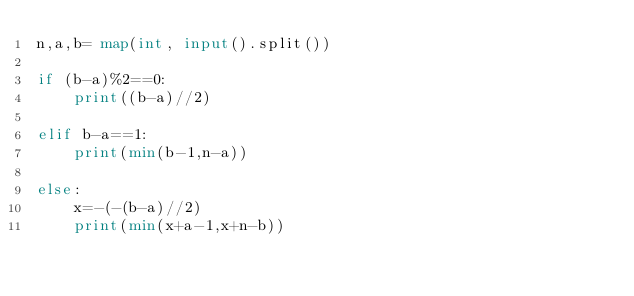<code> <loc_0><loc_0><loc_500><loc_500><_Python_>n,a,b= map(int, input().split())

if (b-a)%2==0:
    print((b-a)//2)

elif b-a==1:
    print(min(b-1,n-a))

else:
    x=-(-(b-a)//2)
    print(min(x+a-1,x+n-b))</code> 